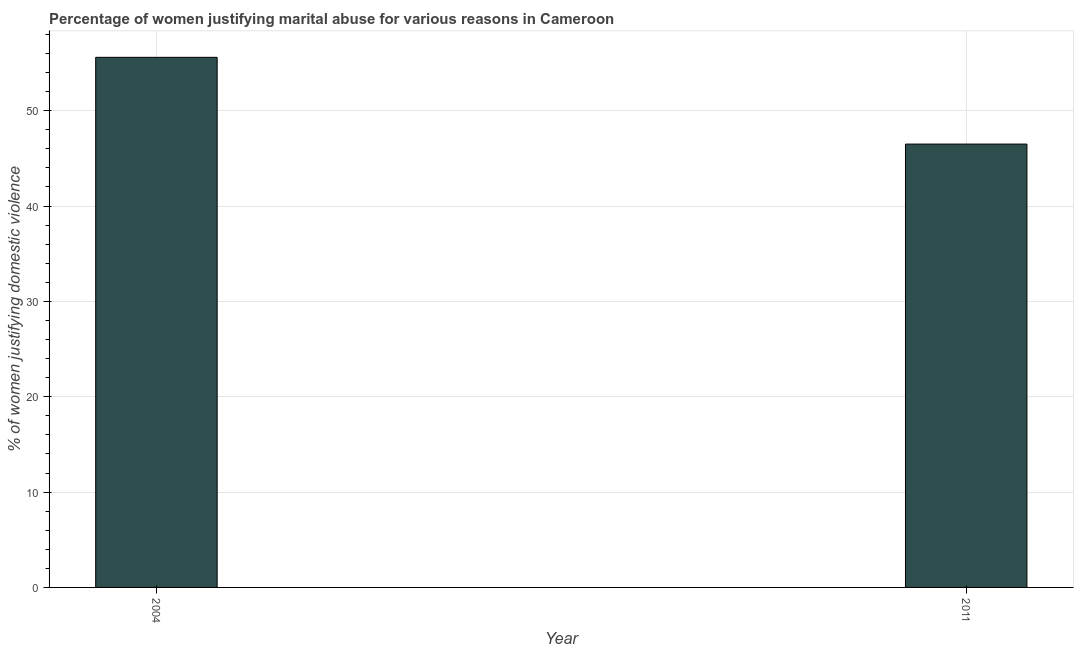Does the graph contain any zero values?
Keep it short and to the point. No. Does the graph contain grids?
Keep it short and to the point. Yes. What is the title of the graph?
Your response must be concise. Percentage of women justifying marital abuse for various reasons in Cameroon. What is the label or title of the Y-axis?
Make the answer very short. % of women justifying domestic violence. What is the percentage of women justifying marital abuse in 2004?
Provide a succinct answer. 55.6. Across all years, what is the maximum percentage of women justifying marital abuse?
Provide a succinct answer. 55.6. Across all years, what is the minimum percentage of women justifying marital abuse?
Ensure brevity in your answer.  46.5. What is the sum of the percentage of women justifying marital abuse?
Make the answer very short. 102.1. What is the difference between the percentage of women justifying marital abuse in 2004 and 2011?
Provide a short and direct response. 9.1. What is the average percentage of women justifying marital abuse per year?
Keep it short and to the point. 51.05. What is the median percentage of women justifying marital abuse?
Keep it short and to the point. 51.05. What is the ratio of the percentage of women justifying marital abuse in 2004 to that in 2011?
Your answer should be very brief. 1.2. Are all the bars in the graph horizontal?
Provide a short and direct response. No. What is the difference between two consecutive major ticks on the Y-axis?
Offer a terse response. 10. What is the % of women justifying domestic violence of 2004?
Keep it short and to the point. 55.6. What is the % of women justifying domestic violence of 2011?
Make the answer very short. 46.5. What is the difference between the % of women justifying domestic violence in 2004 and 2011?
Your answer should be very brief. 9.1. What is the ratio of the % of women justifying domestic violence in 2004 to that in 2011?
Ensure brevity in your answer.  1.2. 